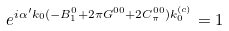<formula> <loc_0><loc_0><loc_500><loc_500>e ^ { i \alpha ^ { \prime } k _ { 0 } ( - B _ { 1 } ^ { 0 } + 2 \pi G ^ { 0 0 } + 2 C _ { \pi } ^ { 0 0 } ) k _ { 0 } ^ { ( c ) } } = 1</formula> 